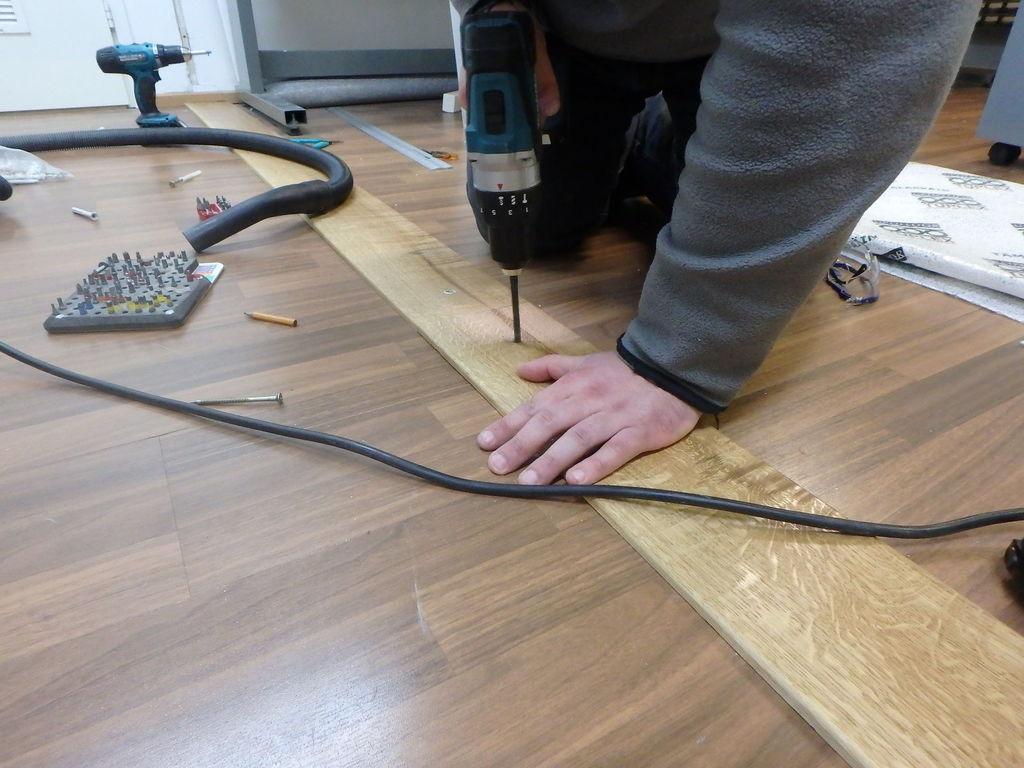Could you give a brief overview of what you see in this image? In this picture we can see a person holding a drilling machine with his hand and on the floor we can see a spectacle, pencil, screws, wire, pipe and some objects and in the background we can see a door. 